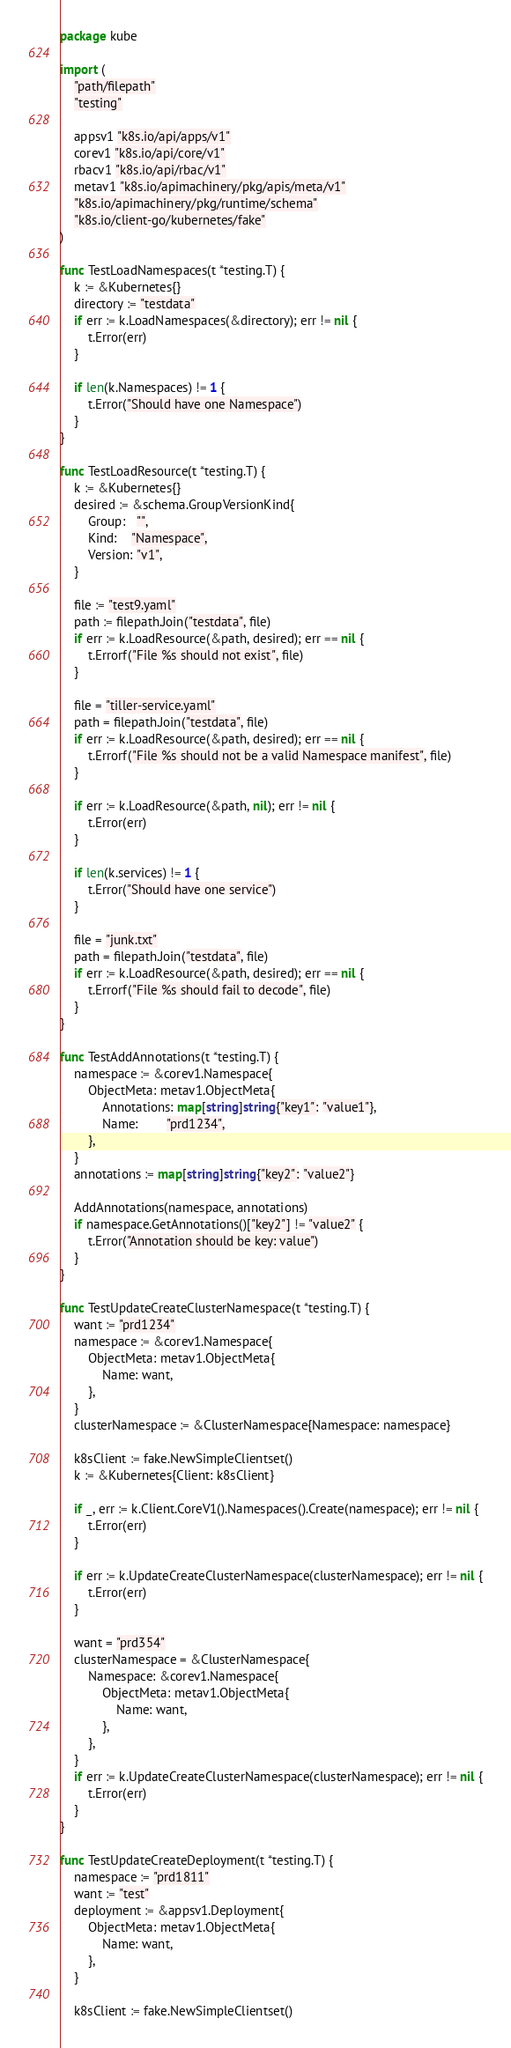Convert code to text. <code><loc_0><loc_0><loc_500><loc_500><_Go_>package kube

import (
	"path/filepath"
	"testing"

	appsv1 "k8s.io/api/apps/v1"
	corev1 "k8s.io/api/core/v1"
	rbacv1 "k8s.io/api/rbac/v1"
	metav1 "k8s.io/apimachinery/pkg/apis/meta/v1"
	"k8s.io/apimachinery/pkg/runtime/schema"
	"k8s.io/client-go/kubernetes/fake"
)

func TestLoadNamespaces(t *testing.T) {
	k := &Kubernetes{}
	directory := "testdata"
	if err := k.LoadNamespaces(&directory); err != nil {
		t.Error(err)
	}

	if len(k.Namespaces) != 1 {
		t.Error("Should have one Namespace")
	}
}

func TestLoadResource(t *testing.T) {
	k := &Kubernetes{}
	desired := &schema.GroupVersionKind{
		Group:   "",
		Kind:    "Namespace",
		Version: "v1",
	}

	file := "test9.yaml"
	path := filepath.Join("testdata", file)
	if err := k.LoadResource(&path, desired); err == nil {
		t.Errorf("File %s should not exist", file)
	}

	file = "tiller-service.yaml"
	path = filepath.Join("testdata", file)
	if err := k.LoadResource(&path, desired); err == nil {
		t.Errorf("File %s should not be a valid Namespace manifest", file)
	}

	if err := k.LoadResource(&path, nil); err != nil {
		t.Error(err)
	}

	if len(k.services) != 1 {
		t.Error("Should have one service")
	}

	file = "junk.txt"
	path = filepath.Join("testdata", file)
	if err := k.LoadResource(&path, desired); err == nil {
		t.Errorf("File %s should fail to decode", file)
	}
}

func TestAddAnnotations(t *testing.T) {
	namespace := &corev1.Namespace{
		ObjectMeta: metav1.ObjectMeta{
			Annotations: map[string]string{"key1": "value1"},
			Name:        "prd1234",
		},
	}
	annotations := map[string]string{"key2": "value2"}

	AddAnnotations(namespace, annotations)
	if namespace.GetAnnotations()["key2"] != "value2" {
		t.Error("Annotation should be key: value")
	}
}

func TestUpdateCreateClusterNamespace(t *testing.T) {
	want := "prd1234"
	namespace := &corev1.Namespace{
		ObjectMeta: metav1.ObjectMeta{
			Name: want,
		},
	}
	clusterNamespace := &ClusterNamespace{Namespace: namespace}

	k8sClient := fake.NewSimpleClientset()
	k := &Kubernetes{Client: k8sClient}

	if _, err := k.Client.CoreV1().Namespaces().Create(namespace); err != nil {
		t.Error(err)
	}

	if err := k.UpdateCreateClusterNamespace(clusterNamespace); err != nil {
		t.Error(err)
	}

	want = "prd354"
	clusterNamespace = &ClusterNamespace{
		Namespace: &corev1.Namespace{
			ObjectMeta: metav1.ObjectMeta{
				Name: want,
			},
		},
	}
	if err := k.UpdateCreateClusterNamespace(clusterNamespace); err != nil {
		t.Error(err)
	}
}

func TestUpdateCreateDeployment(t *testing.T) {
	namespace := "prd1811"
	want := "test"
	deployment := &appsv1.Deployment{
		ObjectMeta: metav1.ObjectMeta{
			Name: want,
		},
	}

	k8sClient := fake.NewSimpleClientset()</code> 